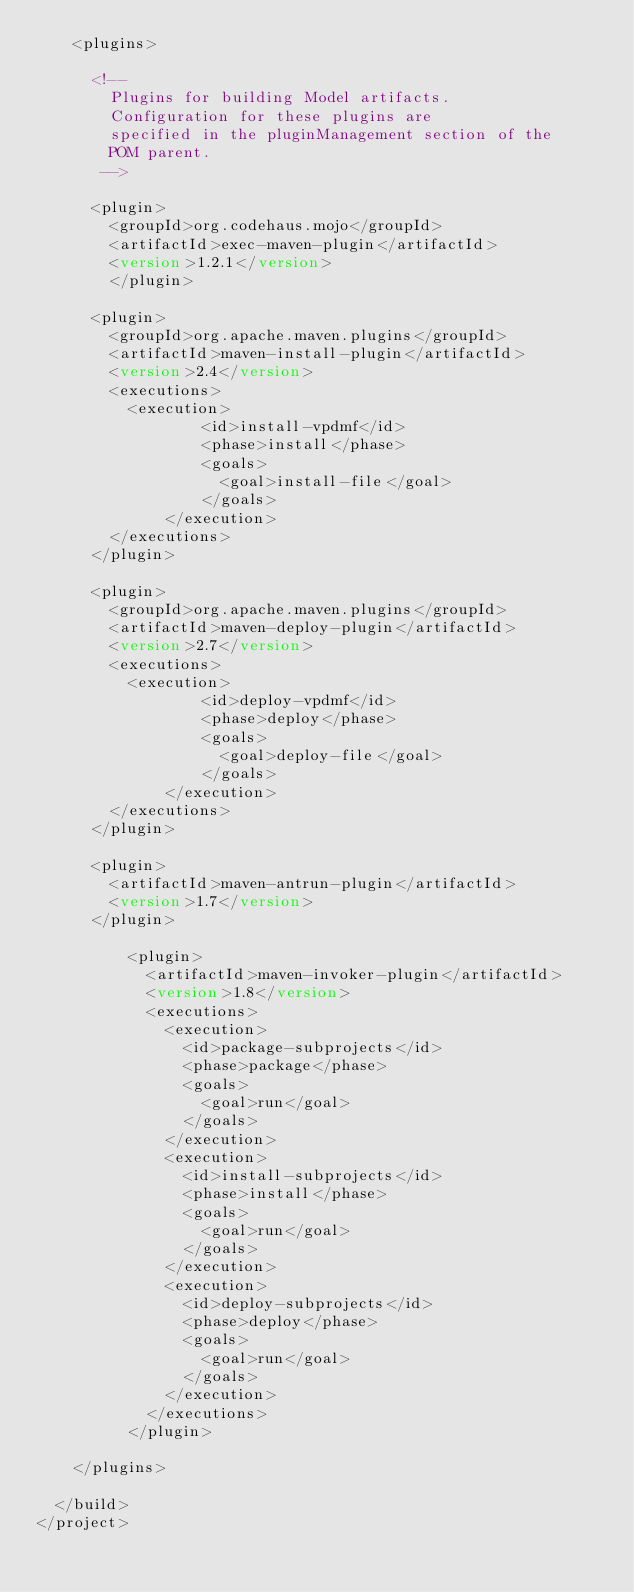Convert code to text. <code><loc_0><loc_0><loc_500><loc_500><_XML_> 		<plugins>
 		
 			<!-- 
 				Plugins for building Model artifacts.
 				Configuration for these plugins are
 				specified in the pluginManagement section of the 
 				POM parent.
 			 -->
 			 
 			<plugin>
 				<groupId>org.codehaus.mojo</groupId>
 				<artifactId>exec-maven-plugin</artifactId>
 				<version>1.2.1</version>
  			</plugin>
 			
 			<plugin>
				<groupId>org.apache.maven.plugins</groupId>
				<artifactId>maven-install-plugin</artifactId>
				<version>2.4</version>
 				<executions>
 					<execution>
			            <id>install-vpdmf</id>
			            <phase>install</phase>
			            <goals>
			              <goal>install-file</goal>
			            </goals>
			        </execution>
 				</executions>
 			</plugin>
  			
 			<plugin>
				<groupId>org.apache.maven.plugins</groupId>
				<artifactId>maven-deploy-plugin</artifactId>
				<version>2.7</version>
 				<executions>
 					<execution>
			            <id>deploy-vpdmf</id>
			            <phase>deploy</phase>
			            <goals>
			              <goal>deploy-file</goal>
			            </goals>
			        </execution>
 				</executions>
 			</plugin>

			<plugin>
				<artifactId>maven-antrun-plugin</artifactId>
				<version>1.7</version>
			</plugin>
	 		
		      <plugin>
		        <artifactId>maven-invoker-plugin</artifactId>
		        <version>1.8</version>
		        <executions>
		          <execution>
		            <id>package-subprojects</id>
		            <phase>package</phase>
		            <goals>
		              <goal>run</goal>
		            </goals>
		          </execution>
		          <execution>
		            <id>install-subprojects</id>
		            <phase>install</phase>
		            <goals>
		              <goal>run</goal>
		            </goals>
		          </execution>
		          <execution>
		            <id>deploy-subprojects</id>
		            <phase>deploy</phase>
		            <goals>
		              <goal>run</goal>
		            </goals>
		          </execution>
		        </executions>
		      </plugin>
  			
 		</plugins>
 		 		
 	</build>
</project></code> 